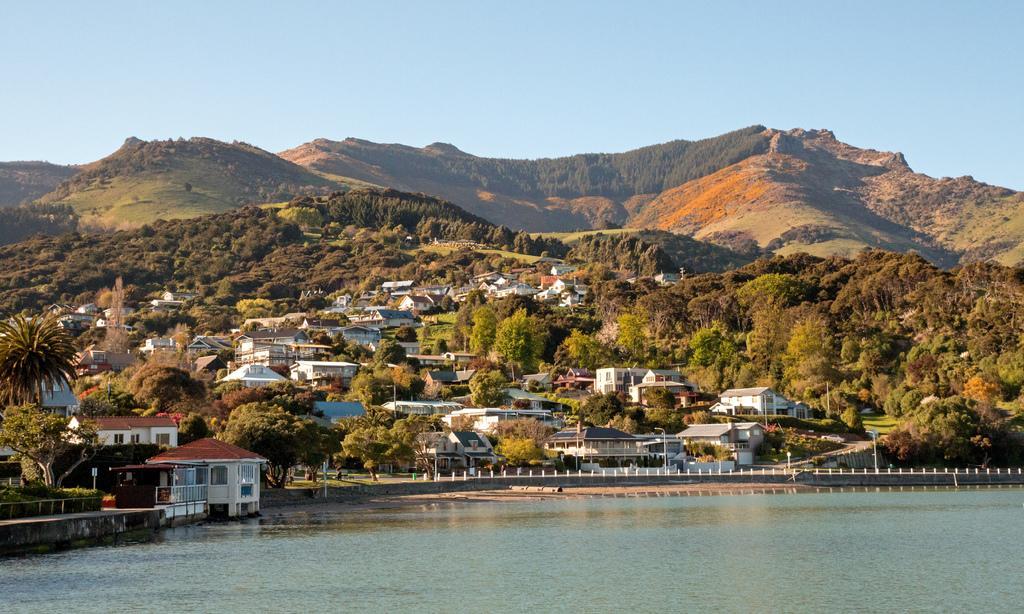Could you give a brief overview of what you see in this image? Here is the water flowing. These are the houses. I can see the trees and bushes. This looks like a road. These are the mountains. 